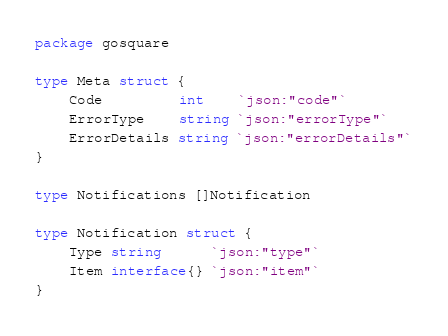Convert code to text. <code><loc_0><loc_0><loc_500><loc_500><_Go_>package gosquare

type Meta struct {
	Code         int    `json:"code"`
	ErrorType    string `json:"errorType"`
	ErrorDetails string `json:"errorDetails"`
}

type Notifications []Notification

type Notification struct {
	Type string      `json:"type"`
	Item interface{} `json:"item"`
}
</code> 